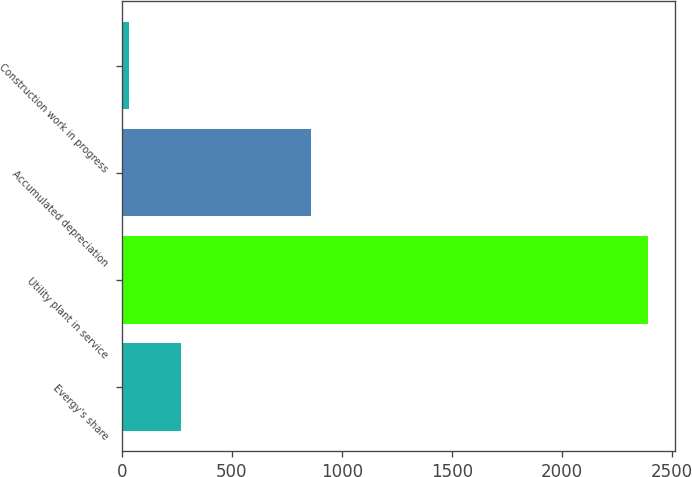Convert chart to OTSL. <chart><loc_0><loc_0><loc_500><loc_500><bar_chart><fcel>Evergy's share<fcel>Utility plant in service<fcel>Accumulated depreciation<fcel>Construction work in progress<nl><fcel>269.13<fcel>2392.5<fcel>861<fcel>33.2<nl></chart> 